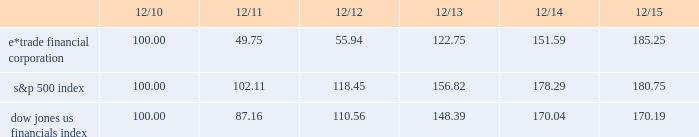Table of contents performance graph the following performance graph shows the cumulative total return to a holder of the company 2019s common stock , assuming dividend reinvestment , compared with the cumulative total return , assuming dividend reinvestment , of the standard & poor ( "s&p" ) 500 index and the dow jones us financials index during the period from december 31 , 2010 through december 31 , 2015. .

What was the percentage cumulative total return for e*trade financial corporation for the five years ended 12/15? 
Computations: ((185.25 - 100) / 100)
Answer: 0.8525. 